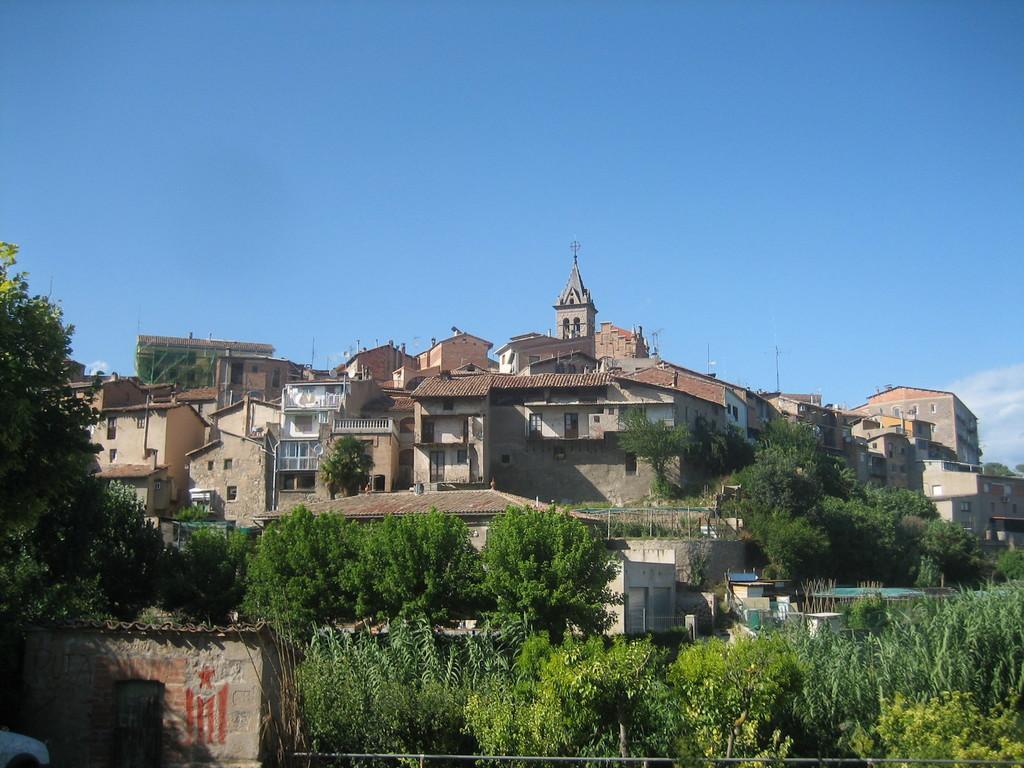Could you give a brief overview of what you see in this image? This image consists of many houses. At the top, there is sky. In the front, we can see many plants and trees. On the left, there is a small room. 